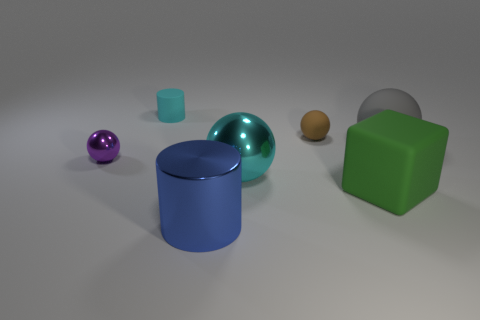Are there any big cyan balls made of the same material as the tiny cylinder?
Provide a short and direct response. No. The tiny thing that is both to the left of the brown object and in front of the small cyan thing has what shape?
Make the answer very short. Sphere. How many tiny things are either balls or yellow cubes?
Your answer should be compact. 2. What material is the large blue object?
Ensure brevity in your answer.  Metal. How many other things are the same shape as the blue shiny object?
Offer a terse response. 1. How big is the blue metallic cylinder?
Keep it short and to the point. Large. There is a sphere that is behind the tiny purple metal ball and on the left side of the large gray matte thing; how big is it?
Offer a terse response. Small. The big object that is in front of the big green thing has what shape?
Keep it short and to the point. Cylinder. Do the small cyan cylinder and the ball in front of the small purple thing have the same material?
Make the answer very short. No. Do the gray thing and the brown object have the same shape?
Make the answer very short. Yes. 